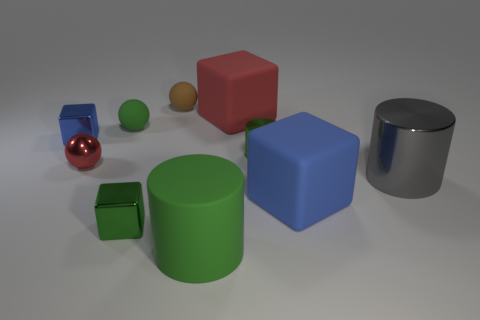Subtract all blue cubes. How many were subtracted if there are1blue cubes left? 1 Subtract 1 cubes. How many cubes are left? 3 Subtract all yellow blocks. Subtract all cyan balls. How many blocks are left? 4 Subtract all cylinders. How many objects are left? 7 Add 7 tiny brown cubes. How many tiny brown cubes exist? 7 Subtract 0 cyan cylinders. How many objects are left? 10 Subtract all cyan rubber cubes. Subtract all green cubes. How many objects are left? 9 Add 8 small green matte objects. How many small green matte objects are left? 9 